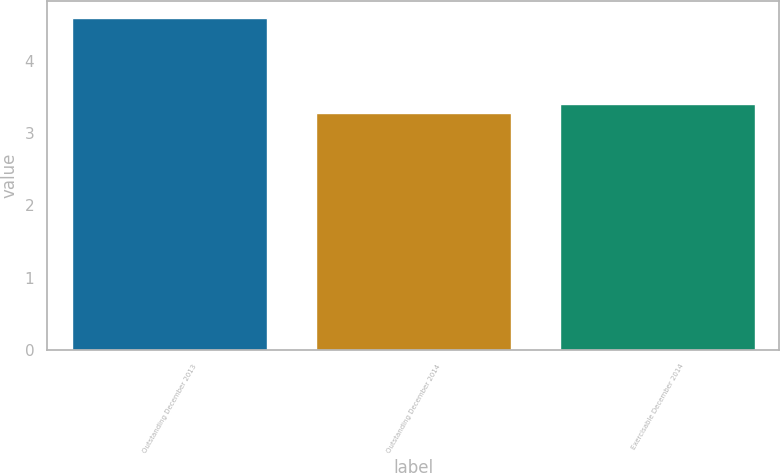Convert chart to OTSL. <chart><loc_0><loc_0><loc_500><loc_500><bar_chart><fcel>Outstanding December 2013<fcel>Outstanding December 2014<fcel>Exercisable December 2014<nl><fcel>4.6<fcel>3.28<fcel>3.41<nl></chart> 